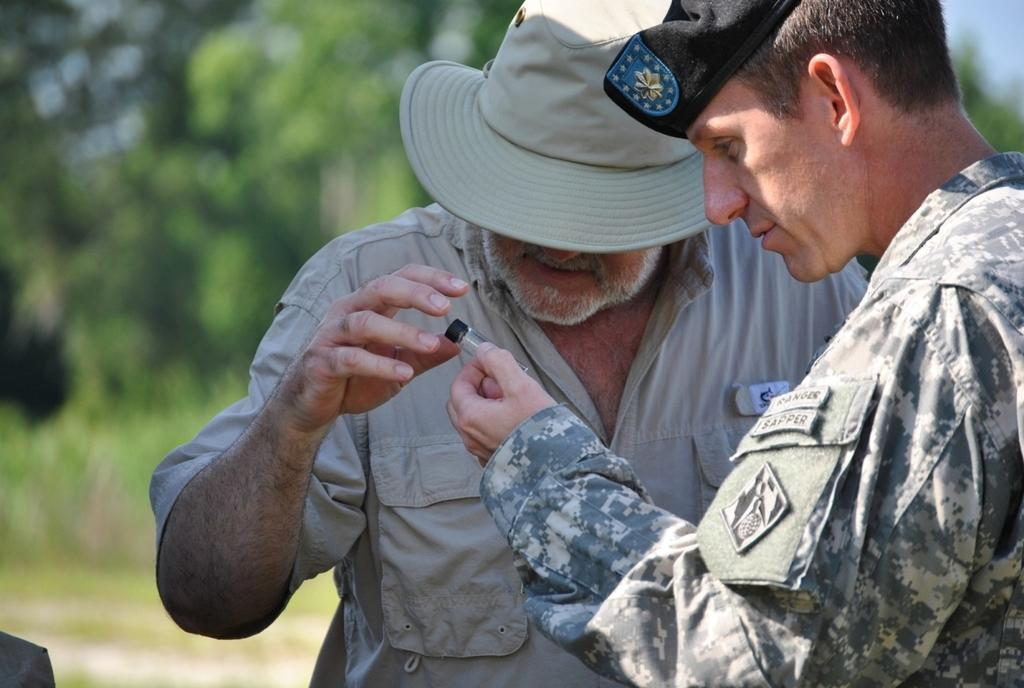What is the primary feature of the image? There are many trees in the image. Can you describe the people in the image? There are two people in the image. What is one person doing in the image? One person is holding an object in their hand. How many snakes can be seen slithering through the trees in the image? There are no snakes visible in the image; it features trees and people. What type of instrument is the person playing in the image? There is no instrument present in the image, and the person is not shown playing any instrument. 